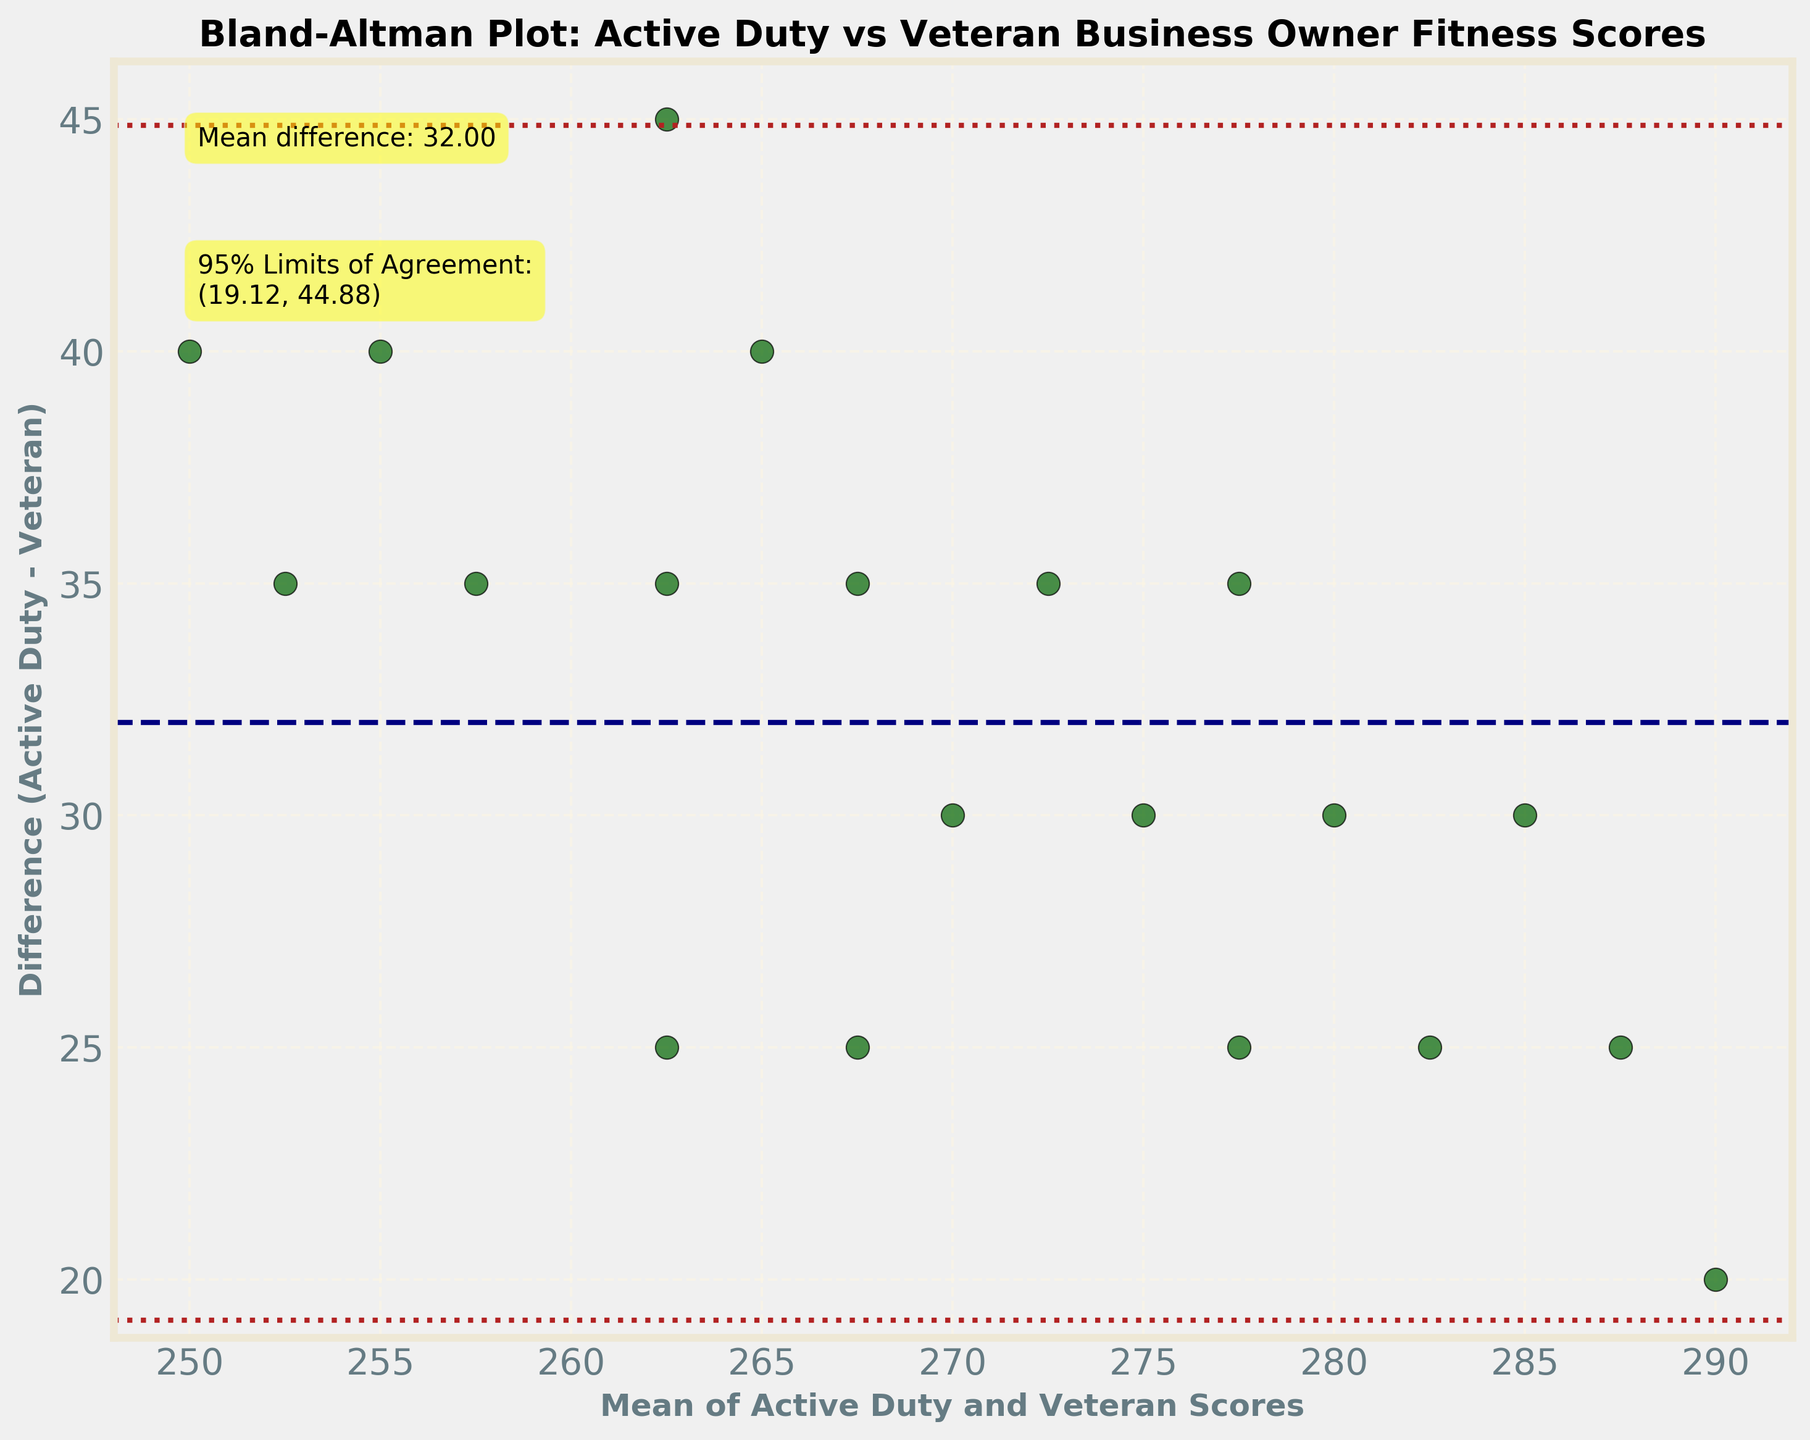What's the title of the plot? The title of the plot is located at the top of the figure.
Answer: Bland-Altman Plot: Active Duty vs Veteran Business Owner Fitness Scores What is the x-axis labeled as? The label for the x-axis is written horizontally underneath the axis.
Answer: Mean of Active Duty and Veteran Scores What is the y-axis labeled as? The label for the y-axis is written vertically beside the axis.
Answer: Difference (Active Duty - Veteran) What are the colors used for the data points and the lines on the plot? Different elements in the plot are color-coded: data points are dark green, the mean difference line is navy, and the limits of agreement lines are firebrick.
Answer: Dark green, navy, firebrick What is the mean difference between the active-duty and veteran scores? The mean difference is annotated on the plot within a yellow box.
Answer: 30.00 What are the 95% limits of agreement? The 95% limits of agreement are annotated on the plot within a yellow box.
Answer: (11.78, 48.22) How many data points are there in total? The data points are represented by scatter points on the plot. Counting them gives the total number.
Answer: 20 What does it mean if a data point lies outside the 95% limits of agreement? A point outside the 95% limits of agreement suggests that the difference between the active-duty and veteran scores for that data point is not within the typical range expected for 95% of the comparisons. This indicates potential outliers or significant discrepancies.
Answer: Outliers or significant discrepancies How does the standard deviation of the differences affect the limits of agreement? The limits of agreement are calculated as the mean difference plus and minus 1.96 times the standard deviation of the differences. A larger standard deviation will result in wider limits, indicating more variability in the differences.
Answer: Wider limits with larger standard deviation Are there more data points where the active-duty score is greater than the veteran score or the other way around? To understand this, we observe the scatter points relative to the y=0 line. Points above this line indicate active-duty scores are greater than veteran scores, while points below indicate the opposite. Count the points above and below the line.
Answer: More points where active-duty score is greater 